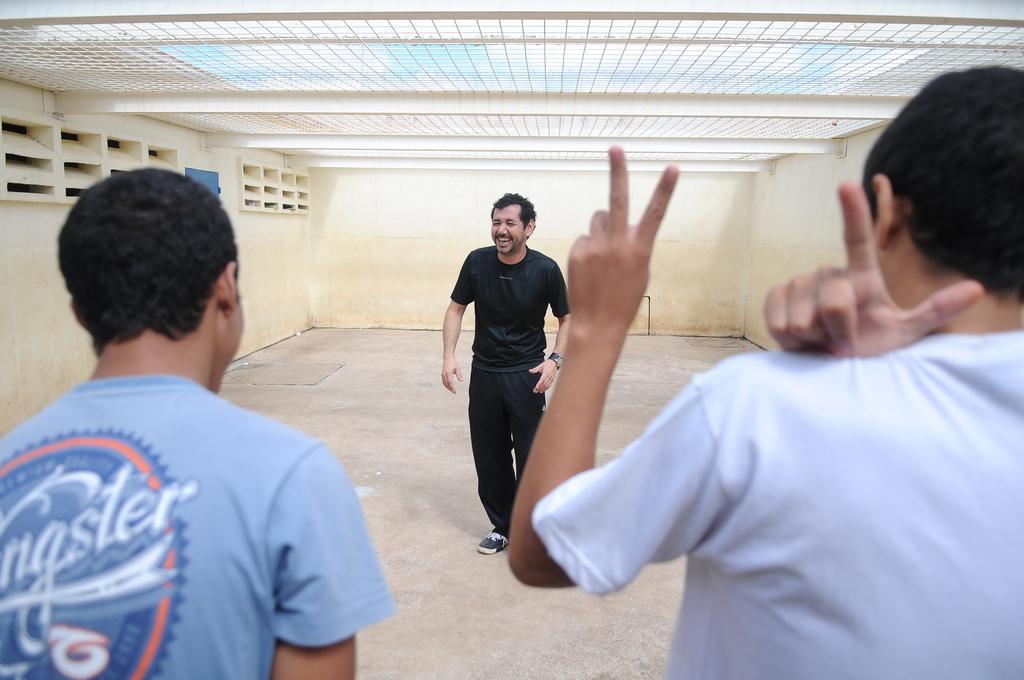How would you summarize this image in a sentence or two? This picture shows the inner view of a building, ceiling grid at the top of the image, three men standing on the floor and one object attached to the wall on the left side of the image. 